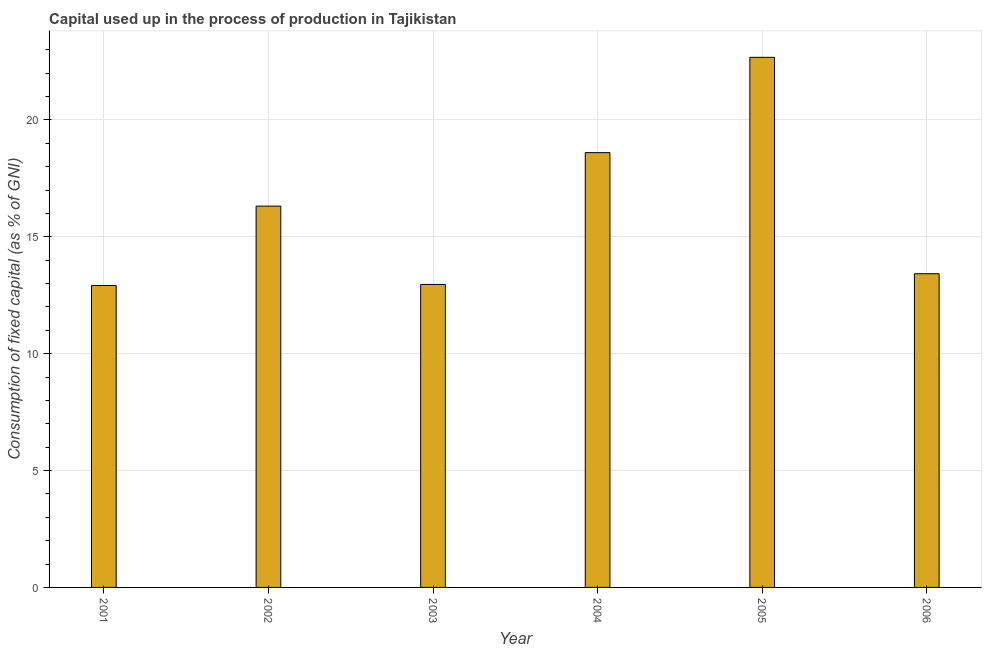Does the graph contain any zero values?
Keep it short and to the point. No. What is the title of the graph?
Make the answer very short. Capital used up in the process of production in Tajikistan. What is the label or title of the X-axis?
Give a very brief answer. Year. What is the label or title of the Y-axis?
Keep it short and to the point. Consumption of fixed capital (as % of GNI). What is the consumption of fixed capital in 2001?
Provide a succinct answer. 12.92. Across all years, what is the maximum consumption of fixed capital?
Your answer should be very brief. 22.68. Across all years, what is the minimum consumption of fixed capital?
Provide a succinct answer. 12.92. In which year was the consumption of fixed capital maximum?
Keep it short and to the point. 2005. In which year was the consumption of fixed capital minimum?
Make the answer very short. 2001. What is the sum of the consumption of fixed capital?
Ensure brevity in your answer.  96.88. What is the difference between the consumption of fixed capital in 2001 and 2003?
Your response must be concise. -0.04. What is the average consumption of fixed capital per year?
Provide a short and direct response. 16.15. What is the median consumption of fixed capital?
Make the answer very short. 14.86. In how many years, is the consumption of fixed capital greater than 18 %?
Keep it short and to the point. 2. Do a majority of the years between 2001 and 2004 (inclusive) have consumption of fixed capital greater than 3 %?
Offer a very short reply. Yes. What is the ratio of the consumption of fixed capital in 2002 to that in 2006?
Ensure brevity in your answer.  1.22. Is the consumption of fixed capital in 2001 less than that in 2002?
Your response must be concise. Yes. What is the difference between the highest and the second highest consumption of fixed capital?
Ensure brevity in your answer.  4.08. What is the difference between the highest and the lowest consumption of fixed capital?
Offer a very short reply. 9.76. In how many years, is the consumption of fixed capital greater than the average consumption of fixed capital taken over all years?
Offer a very short reply. 3. How many bars are there?
Your response must be concise. 6. Are all the bars in the graph horizontal?
Give a very brief answer. No. How many years are there in the graph?
Your answer should be very brief. 6. What is the difference between two consecutive major ticks on the Y-axis?
Give a very brief answer. 5. Are the values on the major ticks of Y-axis written in scientific E-notation?
Your response must be concise. No. What is the Consumption of fixed capital (as % of GNI) of 2001?
Provide a short and direct response. 12.92. What is the Consumption of fixed capital (as % of GNI) of 2002?
Keep it short and to the point. 16.31. What is the Consumption of fixed capital (as % of GNI) of 2003?
Keep it short and to the point. 12.96. What is the Consumption of fixed capital (as % of GNI) in 2004?
Your answer should be compact. 18.6. What is the Consumption of fixed capital (as % of GNI) in 2005?
Ensure brevity in your answer.  22.68. What is the Consumption of fixed capital (as % of GNI) in 2006?
Provide a short and direct response. 13.42. What is the difference between the Consumption of fixed capital (as % of GNI) in 2001 and 2002?
Provide a succinct answer. -3.39. What is the difference between the Consumption of fixed capital (as % of GNI) in 2001 and 2003?
Your answer should be very brief. -0.05. What is the difference between the Consumption of fixed capital (as % of GNI) in 2001 and 2004?
Keep it short and to the point. -5.68. What is the difference between the Consumption of fixed capital (as % of GNI) in 2001 and 2005?
Make the answer very short. -9.76. What is the difference between the Consumption of fixed capital (as % of GNI) in 2001 and 2006?
Provide a short and direct response. -0.5. What is the difference between the Consumption of fixed capital (as % of GNI) in 2002 and 2003?
Your answer should be very brief. 3.35. What is the difference between the Consumption of fixed capital (as % of GNI) in 2002 and 2004?
Give a very brief answer. -2.29. What is the difference between the Consumption of fixed capital (as % of GNI) in 2002 and 2005?
Ensure brevity in your answer.  -6.37. What is the difference between the Consumption of fixed capital (as % of GNI) in 2002 and 2006?
Your response must be concise. 2.89. What is the difference between the Consumption of fixed capital (as % of GNI) in 2003 and 2004?
Offer a very short reply. -5.64. What is the difference between the Consumption of fixed capital (as % of GNI) in 2003 and 2005?
Make the answer very short. -9.71. What is the difference between the Consumption of fixed capital (as % of GNI) in 2003 and 2006?
Your answer should be compact. -0.46. What is the difference between the Consumption of fixed capital (as % of GNI) in 2004 and 2005?
Offer a very short reply. -4.08. What is the difference between the Consumption of fixed capital (as % of GNI) in 2004 and 2006?
Your response must be concise. 5.18. What is the difference between the Consumption of fixed capital (as % of GNI) in 2005 and 2006?
Keep it short and to the point. 9.26. What is the ratio of the Consumption of fixed capital (as % of GNI) in 2001 to that in 2002?
Provide a succinct answer. 0.79. What is the ratio of the Consumption of fixed capital (as % of GNI) in 2001 to that in 2004?
Provide a succinct answer. 0.69. What is the ratio of the Consumption of fixed capital (as % of GNI) in 2001 to that in 2005?
Your response must be concise. 0.57. What is the ratio of the Consumption of fixed capital (as % of GNI) in 2002 to that in 2003?
Give a very brief answer. 1.26. What is the ratio of the Consumption of fixed capital (as % of GNI) in 2002 to that in 2004?
Give a very brief answer. 0.88. What is the ratio of the Consumption of fixed capital (as % of GNI) in 2002 to that in 2005?
Keep it short and to the point. 0.72. What is the ratio of the Consumption of fixed capital (as % of GNI) in 2002 to that in 2006?
Offer a very short reply. 1.22. What is the ratio of the Consumption of fixed capital (as % of GNI) in 2003 to that in 2004?
Ensure brevity in your answer.  0.7. What is the ratio of the Consumption of fixed capital (as % of GNI) in 2003 to that in 2005?
Your response must be concise. 0.57. What is the ratio of the Consumption of fixed capital (as % of GNI) in 2003 to that in 2006?
Offer a very short reply. 0.97. What is the ratio of the Consumption of fixed capital (as % of GNI) in 2004 to that in 2005?
Your answer should be compact. 0.82. What is the ratio of the Consumption of fixed capital (as % of GNI) in 2004 to that in 2006?
Provide a succinct answer. 1.39. What is the ratio of the Consumption of fixed capital (as % of GNI) in 2005 to that in 2006?
Keep it short and to the point. 1.69. 